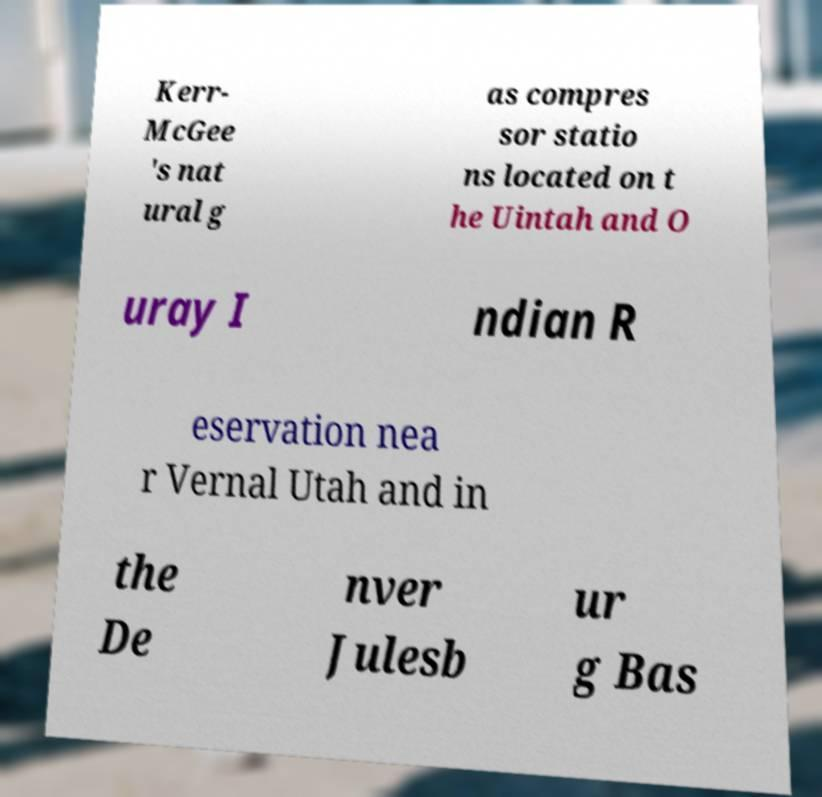What messages or text are displayed in this image? I need them in a readable, typed format. Kerr- McGee 's nat ural g as compres sor statio ns located on t he Uintah and O uray I ndian R eservation nea r Vernal Utah and in the De nver Julesb ur g Bas 